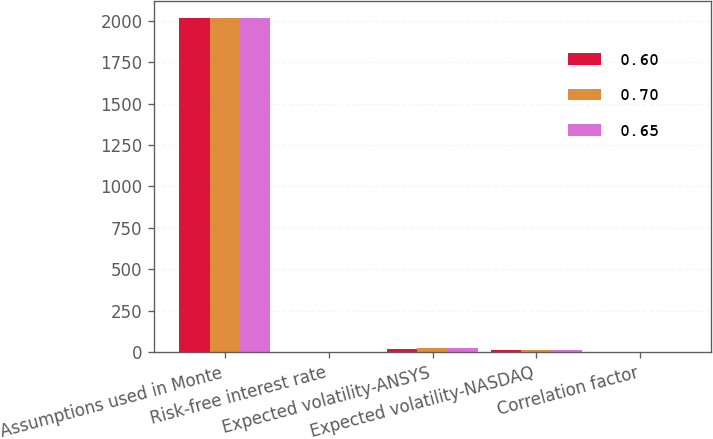Convert chart to OTSL. <chart><loc_0><loc_0><loc_500><loc_500><stacked_bar_chart><ecel><fcel>Assumptions used in Monte<fcel>Risk-free interest rate<fcel>Expected volatility-ANSYS<fcel>Expected volatility-NASDAQ<fcel>Correlation factor<nl><fcel>0.6<fcel>2016<fcel>1<fcel>21<fcel>16<fcel>0.65<nl><fcel>0.7<fcel>2015<fcel>1.1<fcel>23<fcel>14<fcel>0.6<nl><fcel>0.65<fcel>2014<fcel>0.7<fcel>25<fcel>15<fcel>0.7<nl></chart> 